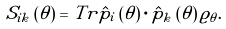<formula> <loc_0><loc_0><loc_500><loc_500>S _ { i k } \left ( \theta \right ) = T r \hat { p } _ { i } \left ( \theta \right ) \cdot \hat { p } _ { k } \left ( \theta \right ) \varrho _ { \theta } .</formula> 